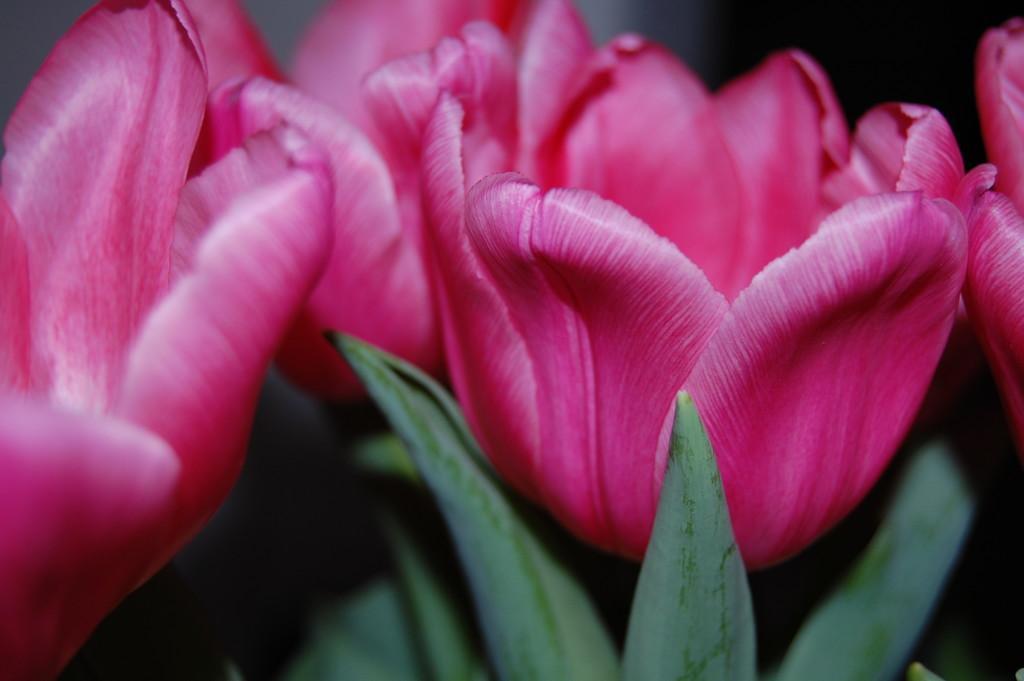Can you describe this image briefly? In this image we can see tulips which are in pink color. At the bottom there are leaves. 